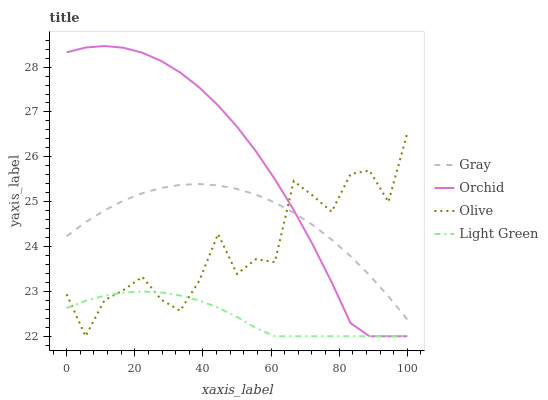Does Light Green have the minimum area under the curve?
Answer yes or no. Yes. Does Orchid have the maximum area under the curve?
Answer yes or no. Yes. Does Gray have the minimum area under the curve?
Answer yes or no. No. Does Gray have the maximum area under the curve?
Answer yes or no. No. Is Light Green the smoothest?
Answer yes or no. Yes. Is Olive the roughest?
Answer yes or no. Yes. Is Gray the smoothest?
Answer yes or no. No. Is Gray the roughest?
Answer yes or no. No. Does Olive have the lowest value?
Answer yes or no. Yes. Does Gray have the lowest value?
Answer yes or no. No. Does Orchid have the highest value?
Answer yes or no. Yes. Does Gray have the highest value?
Answer yes or no. No. Is Light Green less than Gray?
Answer yes or no. Yes. Is Gray greater than Light Green?
Answer yes or no. Yes. Does Orchid intersect Light Green?
Answer yes or no. Yes. Is Orchid less than Light Green?
Answer yes or no. No. Is Orchid greater than Light Green?
Answer yes or no. No. Does Light Green intersect Gray?
Answer yes or no. No. 